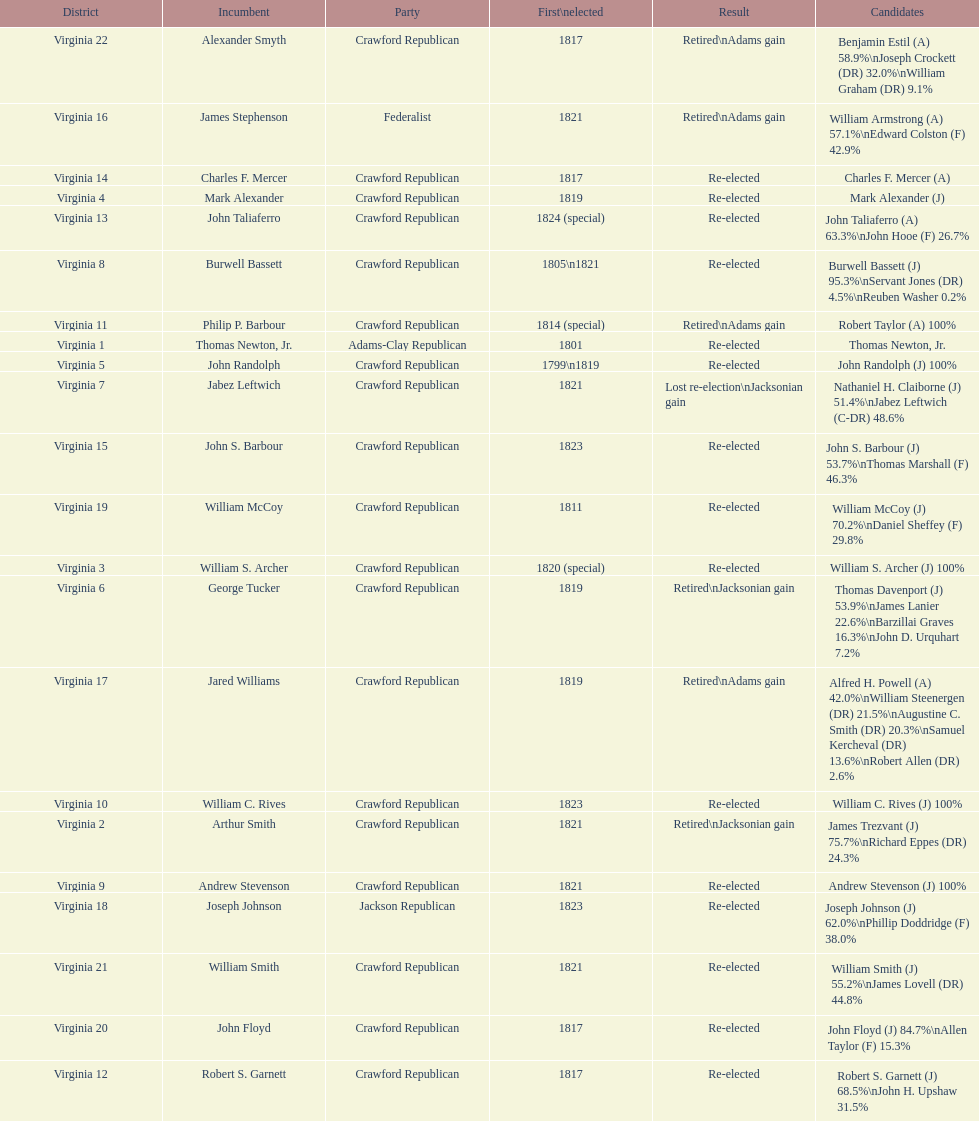Who was the next incumbent after john randolph? George Tucker. 